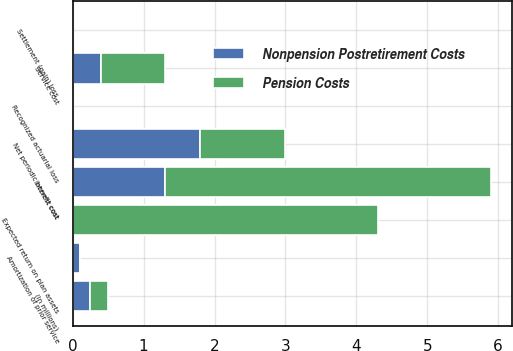Convert chart to OTSL. <chart><loc_0><loc_0><loc_500><loc_500><stacked_bar_chart><ecel><fcel>(In millions)<fcel>Service cost<fcel>Interest cost<fcel>Expected return on plan assets<fcel>Amortization of prior service<fcel>Recognized actuarial loss<fcel>Settlement (gain) loss<fcel>Net periodic benefit cost<nl><fcel>Pension Costs<fcel>0.25<fcel>0.9<fcel>4.6<fcel>4.3<fcel>0<fcel>0<fcel>0<fcel>1.2<nl><fcel>Nonpension Postretirement Costs<fcel>0.25<fcel>0.4<fcel>1.3<fcel>0<fcel>0.1<fcel>0<fcel>0<fcel>1.8<nl></chart> 